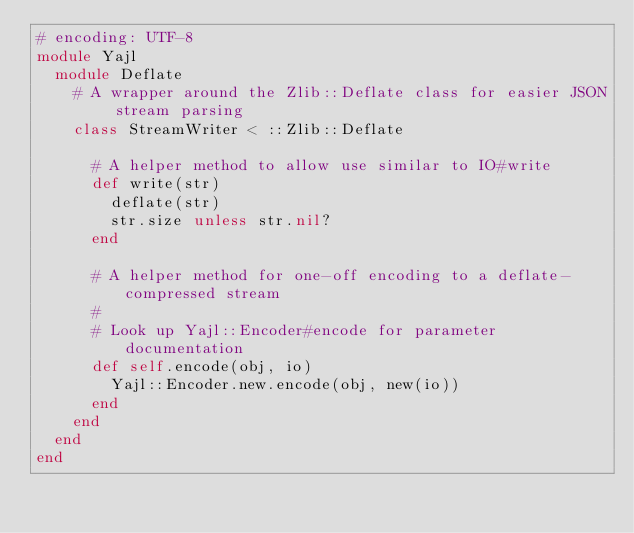<code> <loc_0><loc_0><loc_500><loc_500><_Ruby_># encoding: UTF-8
module Yajl
  module Deflate
    # A wrapper around the Zlib::Deflate class for easier JSON stream parsing
    class StreamWriter < ::Zlib::Deflate

      # A helper method to allow use similar to IO#write
      def write(str)
        deflate(str)
        str.size unless str.nil?
      end

      # A helper method for one-off encoding to a deflate-compressed stream
      #
      # Look up Yajl::Encoder#encode for parameter documentation
      def self.encode(obj, io)
        Yajl::Encoder.new.encode(obj, new(io))
      end
    end
  end
end</code> 